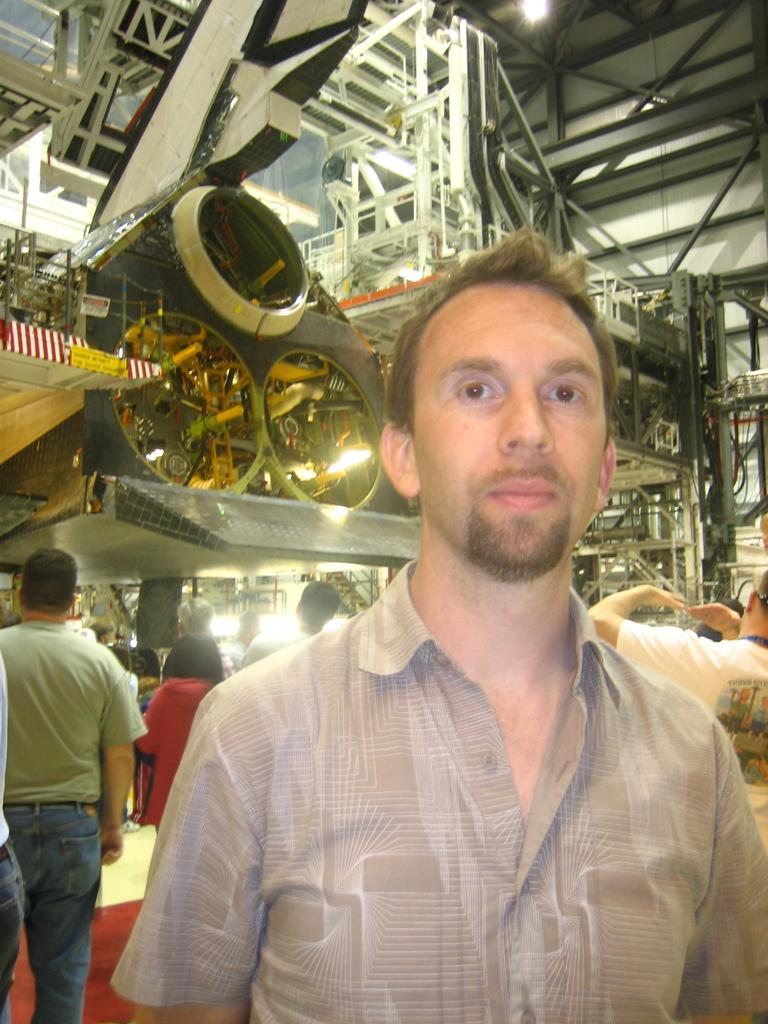How many people are in the image? There are a few people in the image. Where are the people located in the image? The people are standing in an auditorium. What type of arch can be seen in the image? There is no arch present in the image. What type of servant is working in the image? There is no servant present in the image. What type of dust can be seen on the floor in the image? There is no dust present in the image. 